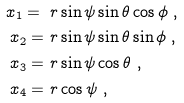<formula> <loc_0><loc_0><loc_500><loc_500>x _ { 1 } = \ & r \sin \psi \sin \theta \cos \phi \ , \\ x _ { 2 } = \ & r \sin \psi \sin \theta \sin \phi \ , \\ x _ { 3 } = \ & r \sin \psi \cos \theta \ , \\ x _ { 4 } = \ & r \cos \psi \ ,</formula> 